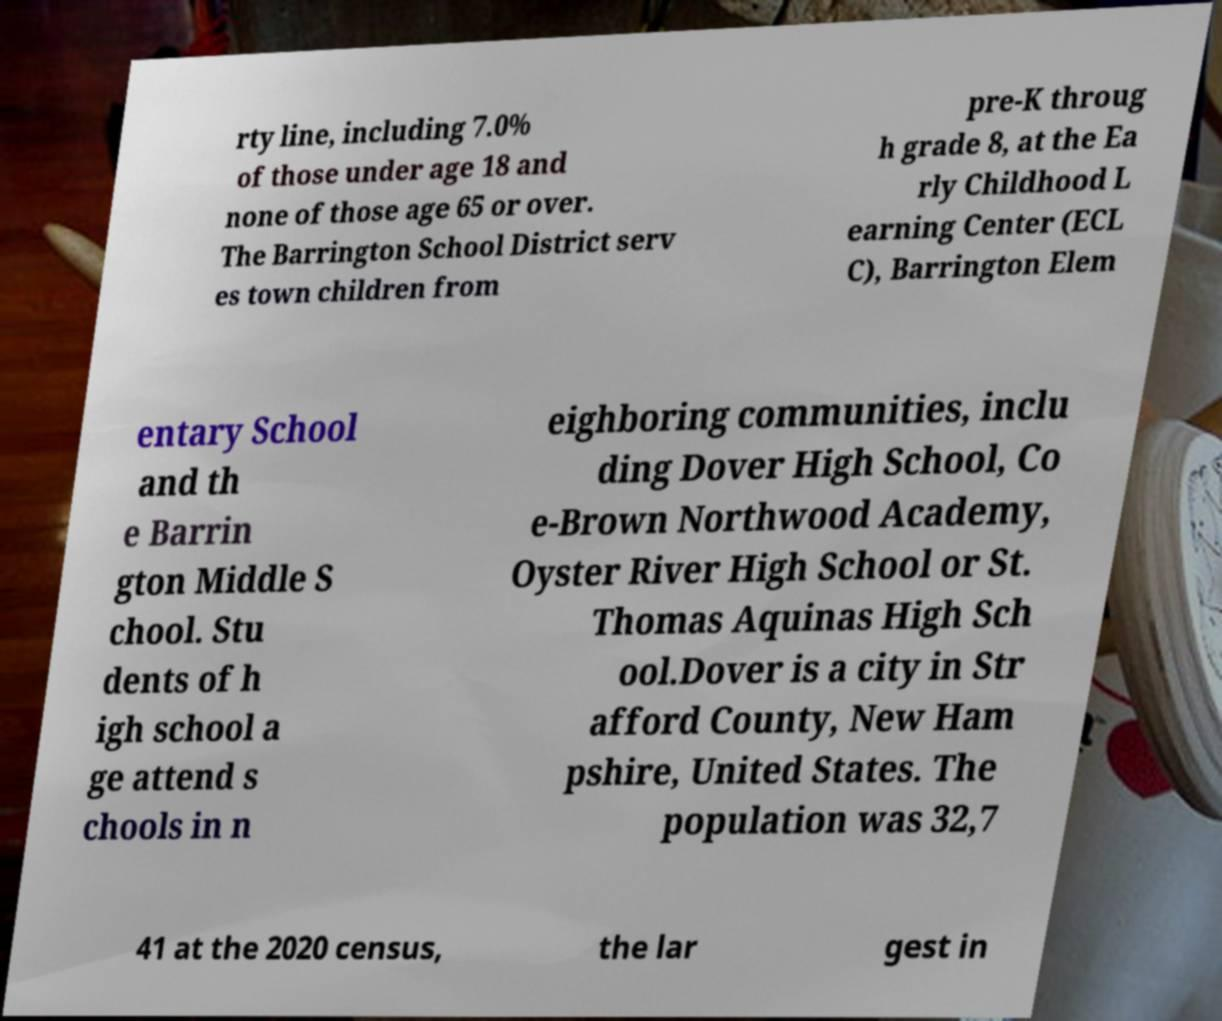Could you extract and type out the text from this image? rty line, including 7.0% of those under age 18 and none of those age 65 or over. The Barrington School District serv es town children from pre-K throug h grade 8, at the Ea rly Childhood L earning Center (ECL C), Barrington Elem entary School and th e Barrin gton Middle S chool. Stu dents of h igh school a ge attend s chools in n eighboring communities, inclu ding Dover High School, Co e-Brown Northwood Academy, Oyster River High School or St. Thomas Aquinas High Sch ool.Dover is a city in Str afford County, New Ham pshire, United States. The population was 32,7 41 at the 2020 census, the lar gest in 